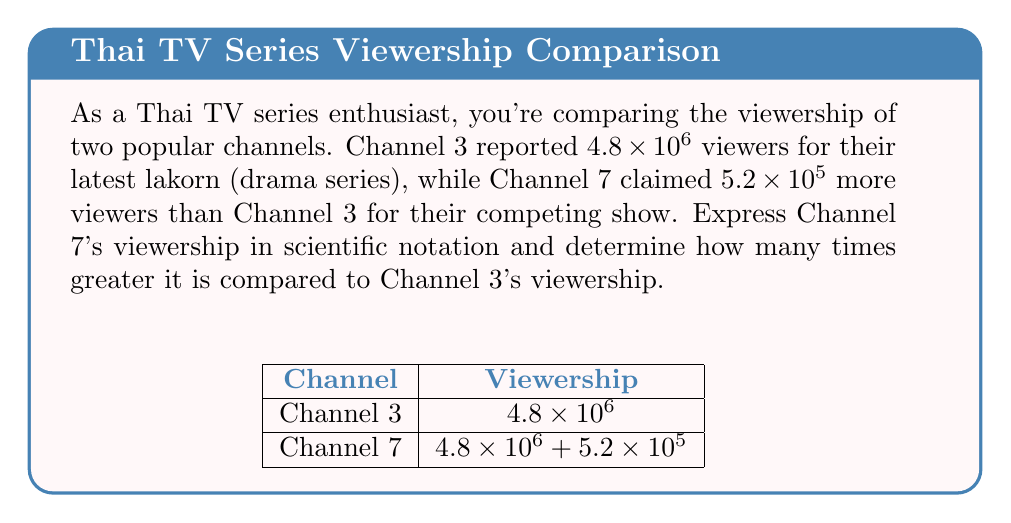Help me with this question. Let's approach this step-by-step:

1) Channel 3's viewership: $4.8 \times 10^6$

2) Channel 7's viewership:
   Channel 7 = Channel 3 + $5.2 \times 10^5$
   $= 4.8 \times 10^6 + 5.2 \times 10^5$

3) To add these, we need to convert $5.2 \times 10^5$ to the same power of 10:
   $5.2 \times 10^5 = 0.52 \times 10^6$

4) Now we can add:
   Channel 7 = $4.8 \times 10^6 + 0.52 \times 10^6$
              $= 5.32 \times 10^6$

5) To find how many times greater Channel 7's viewership is:
   $\frac{\text{Channel 7}}{\text{Channel 3}} = \frac{5.32 \times 10^6}{4.8 \times 10^6}$

6) The $10^6$ cancels out:
   $\frac{5.32}{4.8} = 1.108333...$

7) This can be rounded to 1.11
Answer: $5.32 \times 10^6$; 1.11 times 